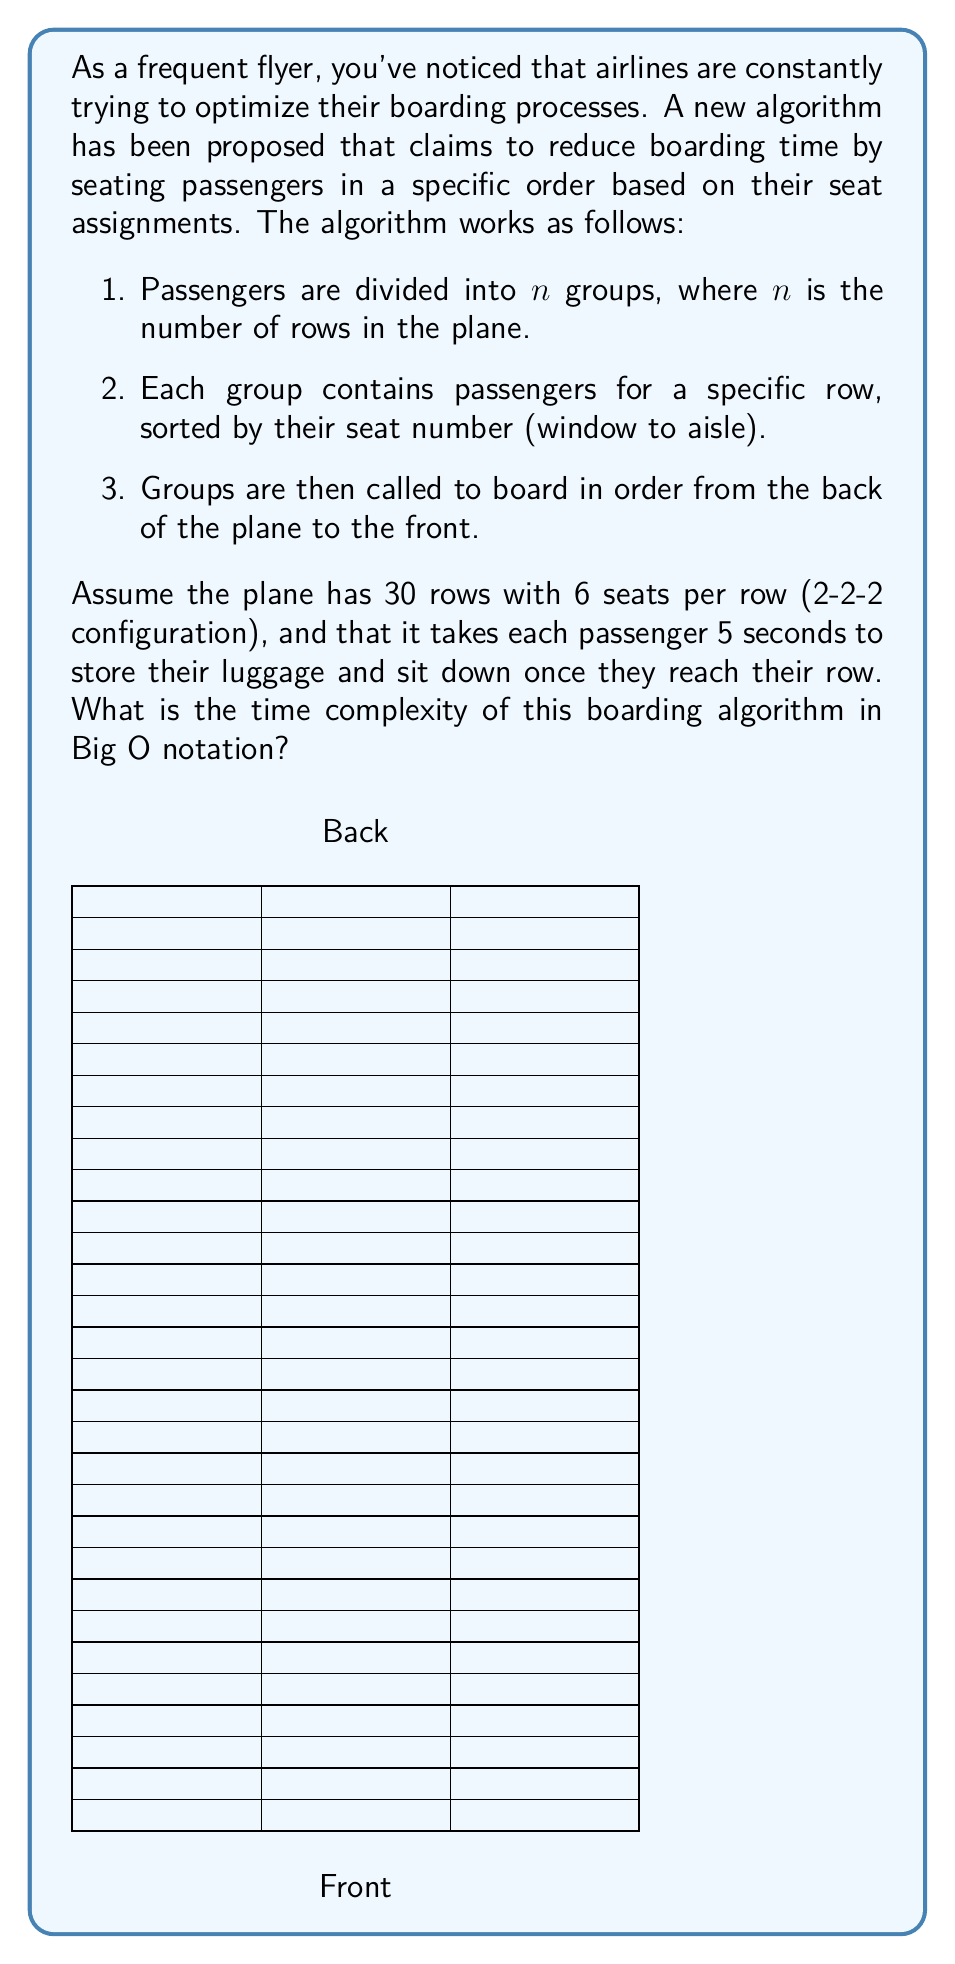Could you help me with this problem? Let's analyze this algorithm step by step:

1) First, we need to consider the preprocessing step where passengers are divided into groups. This requires sorting all passengers, which has a time complexity of $O(n \log n)$, where $n$ is the total number of passengers.

2) Once the passengers are sorted, the actual boarding process begins. For each row:
   - 6 passengers (in this case) need to board
   - Each passenger takes 5 seconds to store luggage and sit down

3) The key observation is that passengers in different rows can store their luggage simultaneously. So, the time for each row is not cumulative.

4) The boarding time for each row is constant (6 * 5 = 30 seconds in this case), regardless of the total number of rows. Let's call this constant $c$.

5) The total boarding time is then $c * n$, where $n$ is the number of rows.

6) In Big O notation, we drop constants. So the time complexity of the boarding process itself is $O(n)$.

7) However, we need to consider the preprocessing step as well. The overall time complexity will be the maximum of the preprocessing step and the boarding process:

   $O(\max(n \log n, n))$

8) Since $n \log n$ grows faster than $n$ for large $n$, the overall time complexity is $O(n \log n)$.

This analysis assumes that the number of seats per row is constant. If it were variable and potentially as large as the number of rows, the analysis would be different.
Answer: $O(n \log n)$ 